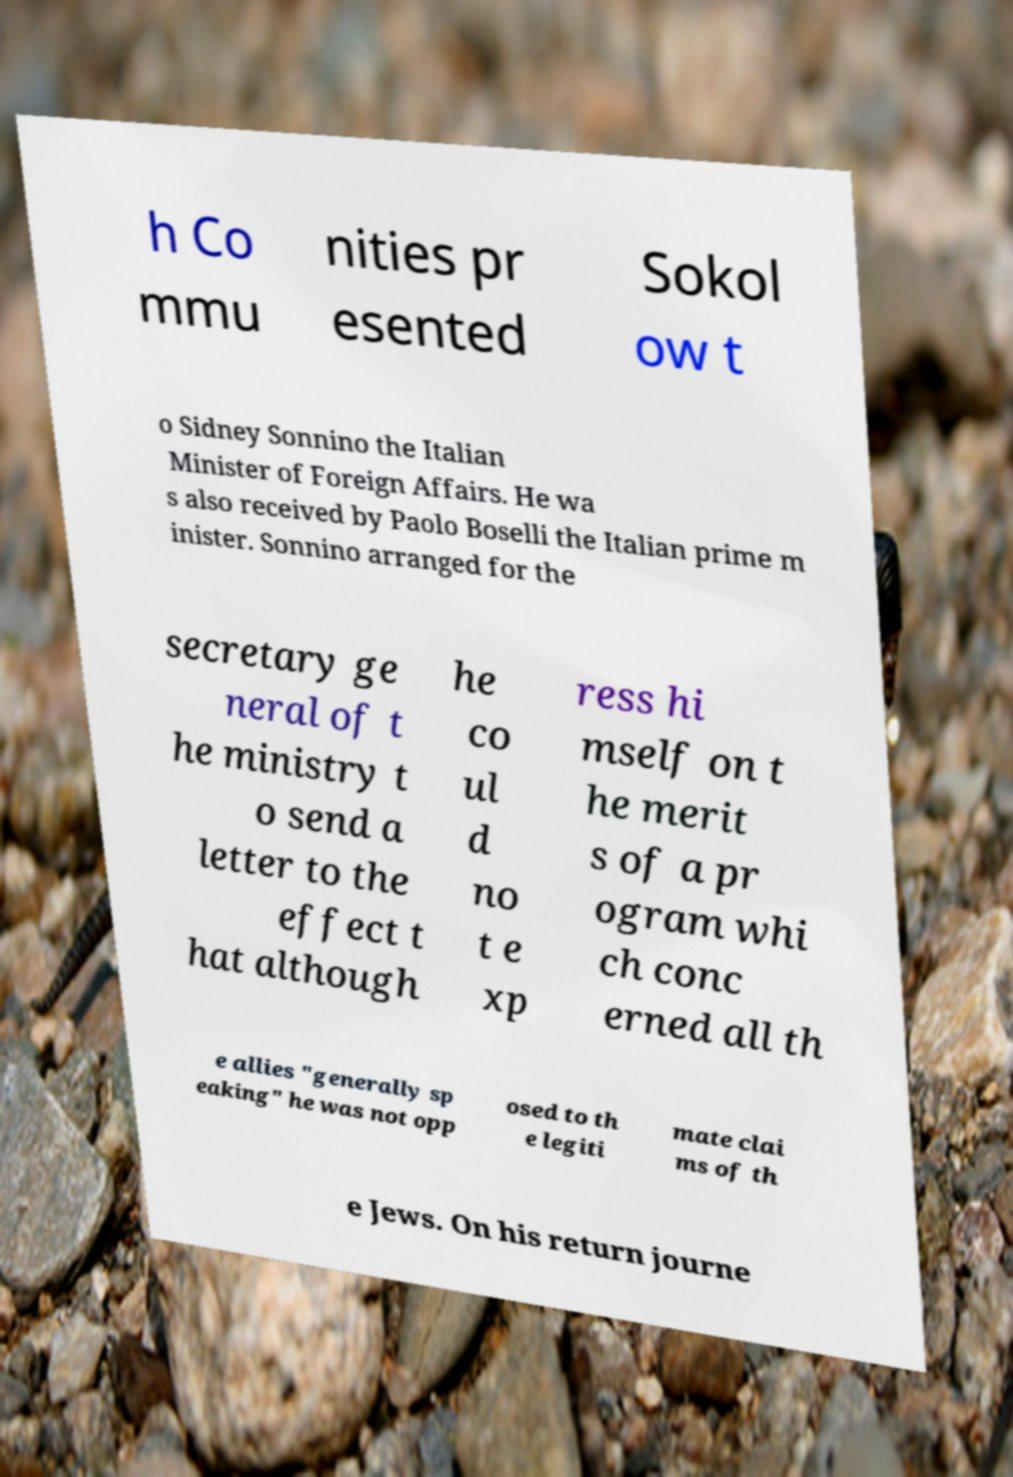Could you extract and type out the text from this image? h Co mmu nities pr esented Sokol ow t o Sidney Sonnino the Italian Minister of Foreign Affairs. He wa s also received by Paolo Boselli the Italian prime m inister. Sonnino arranged for the secretary ge neral of t he ministry t o send a letter to the effect t hat although he co ul d no t e xp ress hi mself on t he merit s of a pr ogram whi ch conc erned all th e allies "generally sp eaking" he was not opp osed to th e legiti mate clai ms of th e Jews. On his return journe 